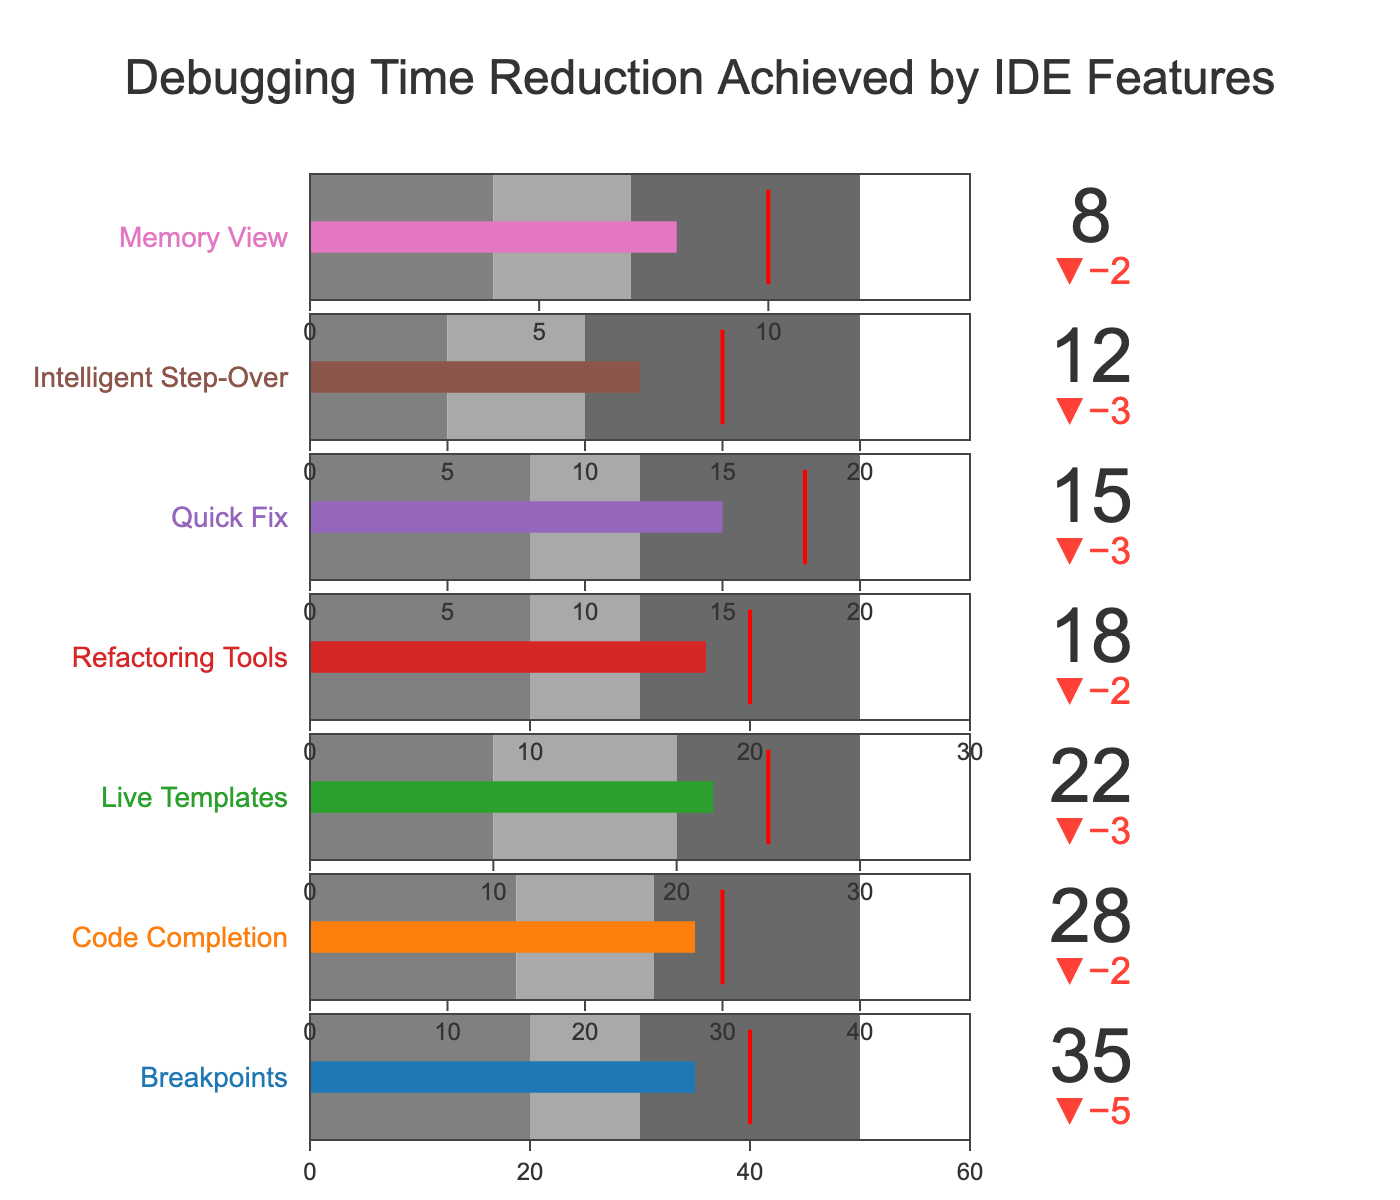What is the title of the figure? The title of the figure is typically placed at the top center and is written in a larger font size compared to other text in the figure. It usually gives a general overview of what the data representation is about.
Answer: Debugging Time Reduction Achieved by IDE Features Which feature has the highest actual debugging time reduction? By analyzing the bars representing the actual values, identify the one with the longest bar, which indicates the highest value.
Answer: Breakpoints What feature has a target reduction of 30? Locate the 'Target' values on the Bullet Chart and find the feature corresponding to a target of 30.
Answer: Code Completion How many features have exceeded their target debugging time reduction? Compare each feature's actual reduction value with its target value; count how many features have an actual value greater than their target value.
Answer: Two Which feature has the smallest actual debugging time reduction, and what is its value? Find the feature with the shortest actual value bar and read its value.
Answer: Memory View (8) Which feature has the most significant difference between its actual and target debugging time reduction? Calculate the differences by subtracting the target values from the actual values for all features, and identify the one with the largest positive difference.
Answer: Breakpoints How does the actual debugging time reduction for Quick Fix compare to its target? Locate the Quick Fix bar and compare its actual value to its target value, noticing whether it is greater, less, or equal.
Answer: Less than Target by 3 What's the average target debugging time reduction across all features? Sum all the target values and divide by the number of features. Calculation: (40 + 30 + 25 + 20 + 18 + 15 + 10) / 7 = 22.57
Answer: 22.57 Which debugging feature falls in the 'Good' performance range and also exceeds its target? Identify features whose actual values are within their defined 'Good' range and verify if their actual values are greater than their target.
Answer: Breakpoints What color represents 'VeryGood' performance, and which feature reaches this category? Observe the color coding in the performance categories and determine the color used for 'VeryGood'. Then check which feature's value falls into this color-coded range.
Answer: Dimgray, Breakpoints 